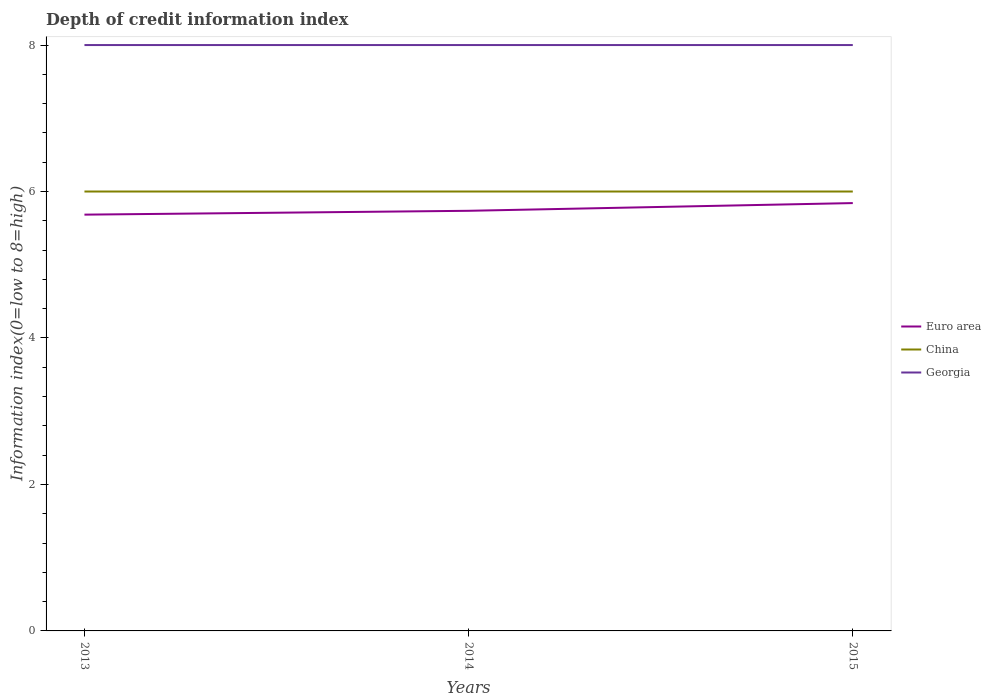Across all years, what is the maximum information index in Euro area?
Provide a succinct answer. 5.68. In which year was the information index in Euro area maximum?
Your answer should be very brief. 2013. What is the total information index in Georgia in the graph?
Make the answer very short. 0. What is the difference between the highest and the second highest information index in Euro area?
Your answer should be very brief. 0.16. How many years are there in the graph?
Keep it short and to the point. 3. What is the difference between two consecutive major ticks on the Y-axis?
Offer a terse response. 2. Does the graph contain any zero values?
Keep it short and to the point. No. Does the graph contain grids?
Make the answer very short. No. Where does the legend appear in the graph?
Offer a terse response. Center right. How many legend labels are there?
Your answer should be very brief. 3. What is the title of the graph?
Provide a short and direct response. Depth of credit information index. What is the label or title of the Y-axis?
Your answer should be very brief. Information index(0=low to 8=high). What is the Information index(0=low to 8=high) of Euro area in 2013?
Ensure brevity in your answer.  5.68. What is the Information index(0=low to 8=high) in China in 2013?
Your answer should be compact. 6. What is the Information index(0=low to 8=high) of Georgia in 2013?
Your response must be concise. 8. What is the Information index(0=low to 8=high) of Euro area in 2014?
Give a very brief answer. 5.74. What is the Information index(0=low to 8=high) of China in 2014?
Offer a terse response. 6. What is the Information index(0=low to 8=high) in Georgia in 2014?
Give a very brief answer. 8. What is the Information index(0=low to 8=high) of Euro area in 2015?
Your response must be concise. 5.84. What is the Information index(0=low to 8=high) in China in 2015?
Provide a succinct answer. 6. What is the Information index(0=low to 8=high) of Georgia in 2015?
Keep it short and to the point. 8. Across all years, what is the maximum Information index(0=low to 8=high) in Euro area?
Keep it short and to the point. 5.84. Across all years, what is the minimum Information index(0=low to 8=high) of Euro area?
Provide a short and direct response. 5.68. Across all years, what is the minimum Information index(0=low to 8=high) in Georgia?
Make the answer very short. 8. What is the total Information index(0=low to 8=high) in Euro area in the graph?
Make the answer very short. 17.26. What is the total Information index(0=low to 8=high) of China in the graph?
Offer a very short reply. 18. What is the difference between the Information index(0=low to 8=high) of Euro area in 2013 and that in 2014?
Your answer should be compact. -0.05. What is the difference between the Information index(0=low to 8=high) of Euro area in 2013 and that in 2015?
Offer a very short reply. -0.16. What is the difference between the Information index(0=low to 8=high) of China in 2013 and that in 2015?
Make the answer very short. 0. What is the difference between the Information index(0=low to 8=high) of Euro area in 2014 and that in 2015?
Make the answer very short. -0.11. What is the difference between the Information index(0=low to 8=high) of Euro area in 2013 and the Information index(0=low to 8=high) of China in 2014?
Make the answer very short. -0.32. What is the difference between the Information index(0=low to 8=high) in Euro area in 2013 and the Information index(0=low to 8=high) in Georgia in 2014?
Provide a succinct answer. -2.32. What is the difference between the Information index(0=low to 8=high) in Euro area in 2013 and the Information index(0=low to 8=high) in China in 2015?
Provide a short and direct response. -0.32. What is the difference between the Information index(0=low to 8=high) in Euro area in 2013 and the Information index(0=low to 8=high) in Georgia in 2015?
Your answer should be compact. -2.32. What is the difference between the Information index(0=low to 8=high) in Euro area in 2014 and the Information index(0=low to 8=high) in China in 2015?
Your answer should be very brief. -0.26. What is the difference between the Information index(0=low to 8=high) in Euro area in 2014 and the Information index(0=low to 8=high) in Georgia in 2015?
Keep it short and to the point. -2.26. What is the average Information index(0=low to 8=high) of Euro area per year?
Keep it short and to the point. 5.75. What is the average Information index(0=low to 8=high) of China per year?
Make the answer very short. 6. In the year 2013, what is the difference between the Information index(0=low to 8=high) of Euro area and Information index(0=low to 8=high) of China?
Give a very brief answer. -0.32. In the year 2013, what is the difference between the Information index(0=low to 8=high) of Euro area and Information index(0=low to 8=high) of Georgia?
Your response must be concise. -2.32. In the year 2013, what is the difference between the Information index(0=low to 8=high) in China and Information index(0=low to 8=high) in Georgia?
Keep it short and to the point. -2. In the year 2014, what is the difference between the Information index(0=low to 8=high) of Euro area and Information index(0=low to 8=high) of China?
Ensure brevity in your answer.  -0.26. In the year 2014, what is the difference between the Information index(0=low to 8=high) of Euro area and Information index(0=low to 8=high) of Georgia?
Keep it short and to the point. -2.26. In the year 2014, what is the difference between the Information index(0=low to 8=high) of China and Information index(0=low to 8=high) of Georgia?
Provide a succinct answer. -2. In the year 2015, what is the difference between the Information index(0=low to 8=high) of Euro area and Information index(0=low to 8=high) of China?
Keep it short and to the point. -0.16. In the year 2015, what is the difference between the Information index(0=low to 8=high) of Euro area and Information index(0=low to 8=high) of Georgia?
Offer a very short reply. -2.16. In the year 2015, what is the difference between the Information index(0=low to 8=high) of China and Information index(0=low to 8=high) of Georgia?
Your answer should be compact. -2. What is the ratio of the Information index(0=low to 8=high) in China in 2013 to that in 2014?
Your response must be concise. 1. What is the ratio of the Information index(0=low to 8=high) of Euro area in 2013 to that in 2015?
Offer a terse response. 0.97. What is the ratio of the Information index(0=low to 8=high) of China in 2013 to that in 2015?
Offer a very short reply. 1. What is the ratio of the Information index(0=low to 8=high) in Georgia in 2013 to that in 2015?
Provide a succinct answer. 1. What is the ratio of the Information index(0=low to 8=high) of China in 2014 to that in 2015?
Provide a short and direct response. 1. What is the ratio of the Information index(0=low to 8=high) of Georgia in 2014 to that in 2015?
Provide a succinct answer. 1. What is the difference between the highest and the second highest Information index(0=low to 8=high) in Euro area?
Keep it short and to the point. 0.11. What is the difference between the highest and the second highest Information index(0=low to 8=high) in Georgia?
Offer a terse response. 0. What is the difference between the highest and the lowest Information index(0=low to 8=high) of Euro area?
Your answer should be compact. 0.16. What is the difference between the highest and the lowest Information index(0=low to 8=high) of Georgia?
Give a very brief answer. 0. 